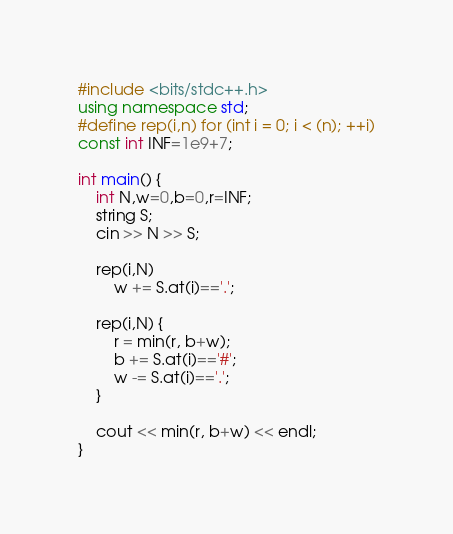Convert code to text. <code><loc_0><loc_0><loc_500><loc_500><_C++_>#include <bits/stdc++.h>
using namespace std;
#define rep(i,n) for (int i = 0; i < (n); ++i)
const int INF=1e9+7;

int main() {
	int N,w=0,b=0,r=INF;
	string S;
	cin >> N >> S;

	rep(i,N)
		w += S.at(i)=='.';

	rep(i,N) {
		r = min(r, b+w);
		b += S.at(i)=='#';
		w -= S.at(i)=='.';
	}

	cout << min(r, b+w) << endl;
}</code> 